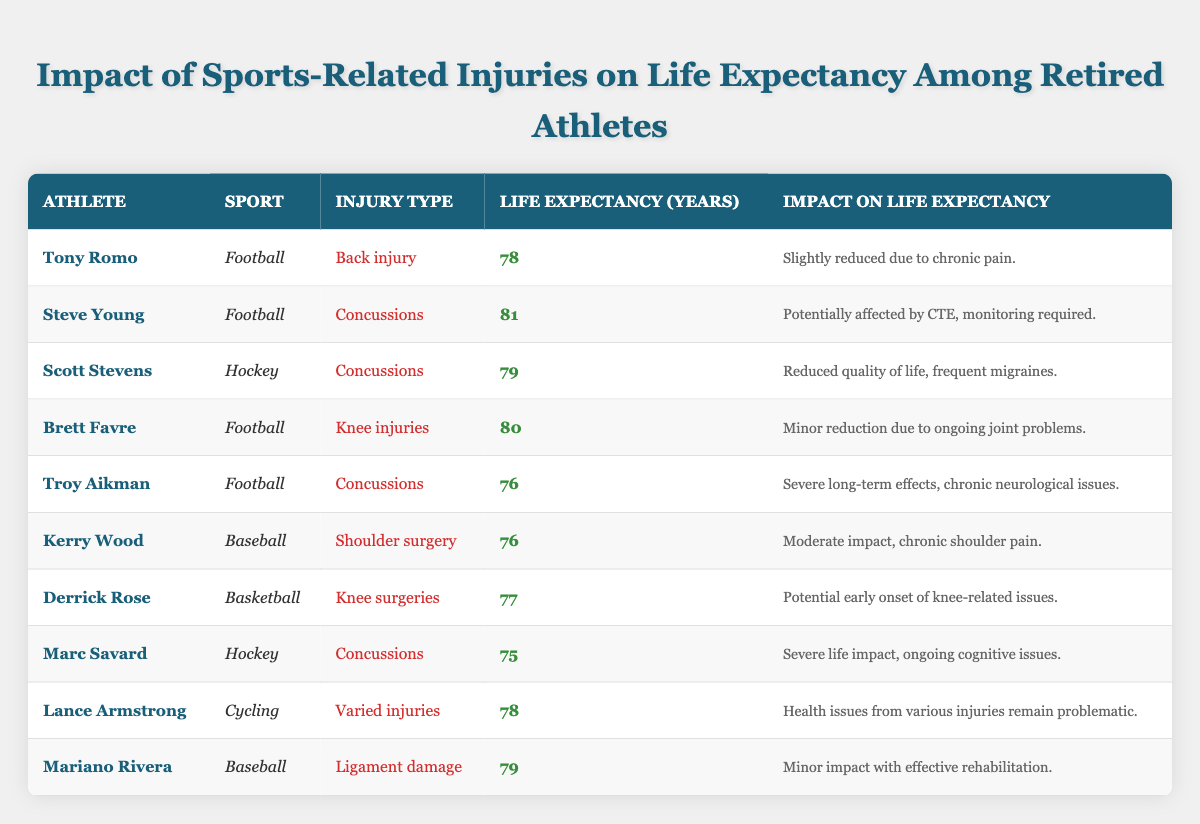What is the life expectancy of Troy Aikman? From the table, under the column "Life Expectancy (Years)", Troy Aikman's life expectancy is explicitly listed as 76 years.
Answer: 76 How many athletes in the table had concussions as their injury type? By scanning the "Injury Type" column, I can count the instances of "Concussions" for athletes: Steve Young, Scott Stevens, Troy Aikman, and Marc Savard. There are a total of 4 athletes.
Answer: 4 Which athlete has the highest life expectancy? To find the highest life expectancy, I compare the values in the "Life Expectancy (Years)" column. Steve Young has the highest value at 81 years.
Answer: 81 What is the average life expectancy of the athletes listed? To calculate the average, I sum all the life expectancy values: 78 + 81 + 79 + 80 + 76 + 76 + 77 + 75 + 78 + 79 = 790. There are 10 athletes, so the average is 790 / 10 = 79.
Answer: 79 Is there an athlete whose life expectancy is above 80 years? By checking the "Life Expectancy (Years)" column, only Steve Young has a value of 81 years, which is above 80.
Answer: Yes Which athlete has the most severe impact on life expectancy? By examining the "Impact on Life Expectancy" column, Marc Savard mentions "Severe life impact, ongoing cognitive issues," indicating the most severe impact compared to others.
Answer: Marc Savard What is the life expectancy difference between the athlete with the highest and lowest life expectancy? The highest life expectancy is 81 years (Steve Young) and the lowest is 75 years (Marc Savard). The difference is 81 - 75 = 6 years.
Answer: 6 years Does chronic pain reduce life expectancy for any athlete in this table? Yes, Tony Romo has a note stating that his life expectancy is "Slightly reduced due to chronic pain".
Answer: Yes Which two athletes have a life expectancy of 78 years? By reviewing the "Life Expectancy (Years)" column, both Tony Romo and Lance Armstrong have a life expectancy of 78 years.
Answer: Tony Romo and Lance Armstrong 